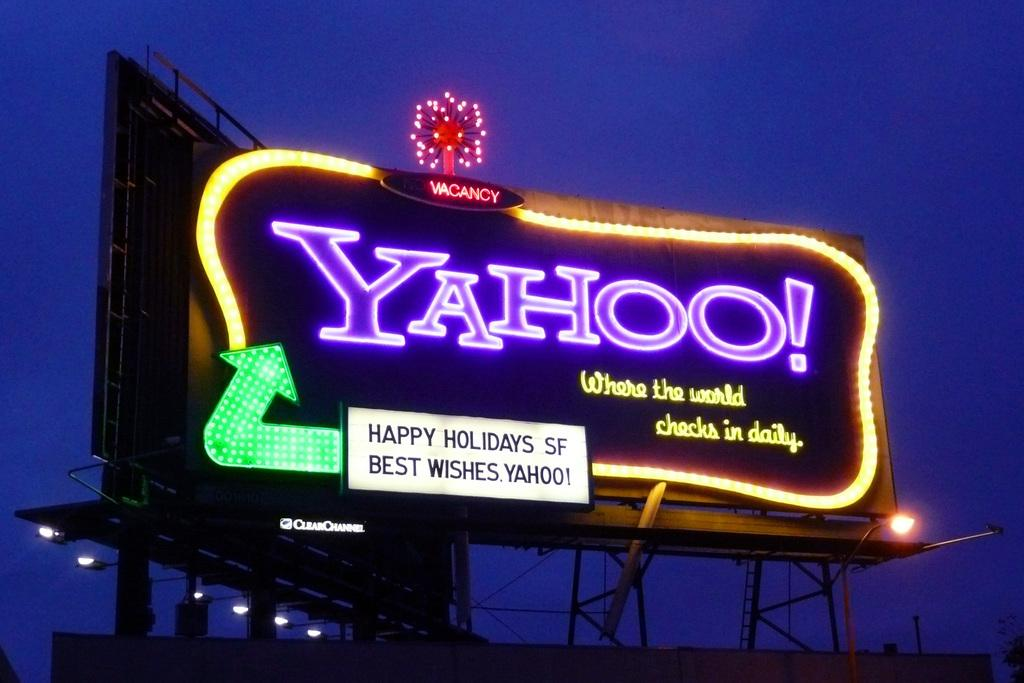<image>
Offer a succinct explanation of the picture presented. Yahoo.com gives a warm holiday greeting to people who pass by. 